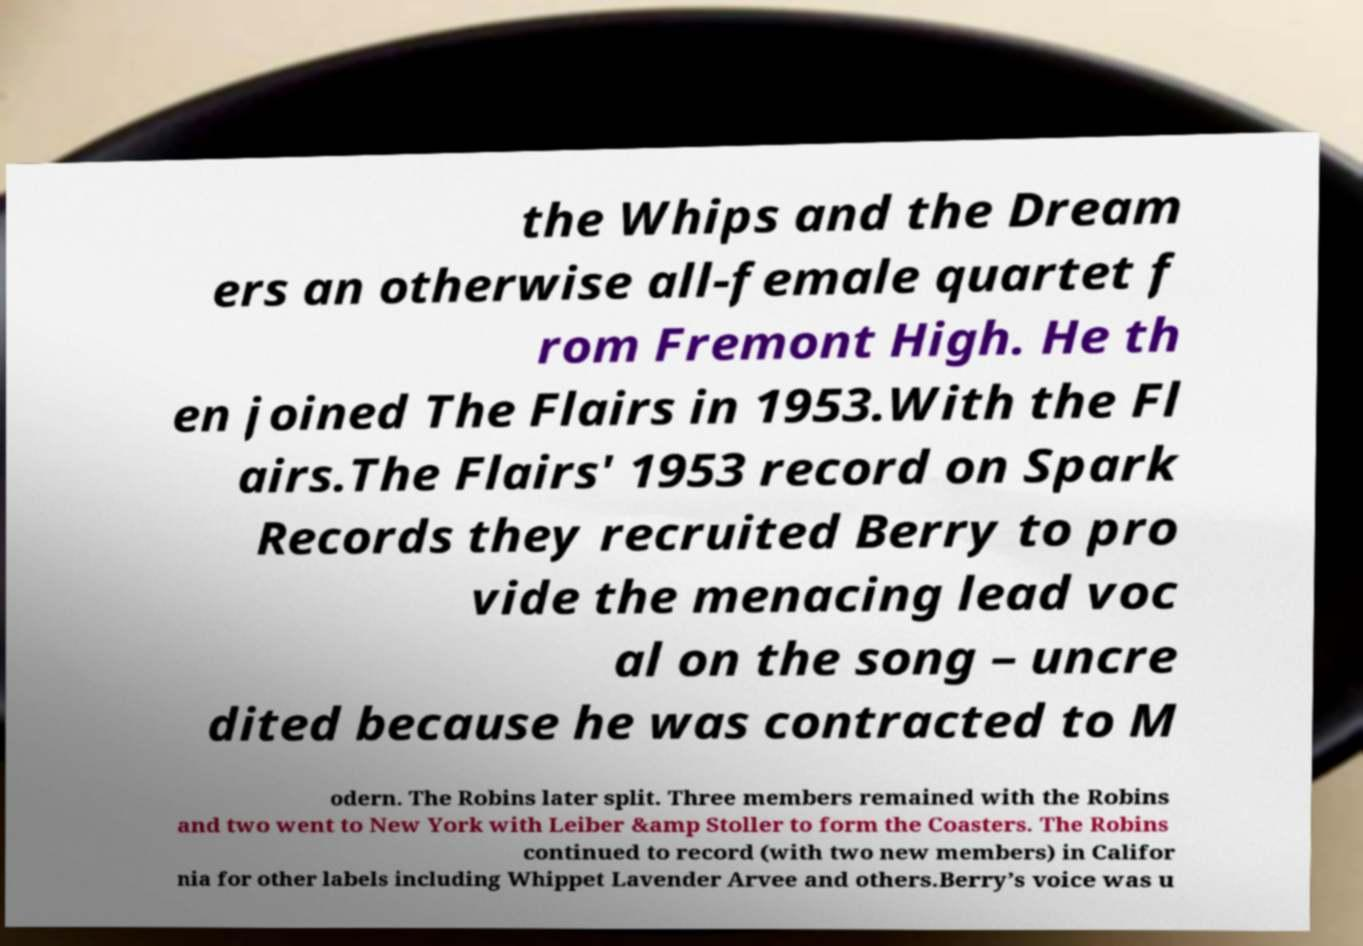Please identify and transcribe the text found in this image. the Whips and the Dream ers an otherwise all-female quartet f rom Fremont High. He th en joined The Flairs in 1953.With the Fl airs.The Flairs' 1953 record on Spark Records they recruited Berry to pro vide the menacing lead voc al on the song – uncre dited because he was contracted to M odern. The Robins later split. Three members remained with the Robins and two went to New York with Leiber &amp Stoller to form the Coasters. The Robins continued to record (with two new members) in Califor nia for other labels including Whippet Lavender Arvee and others.Berry’s voice was u 